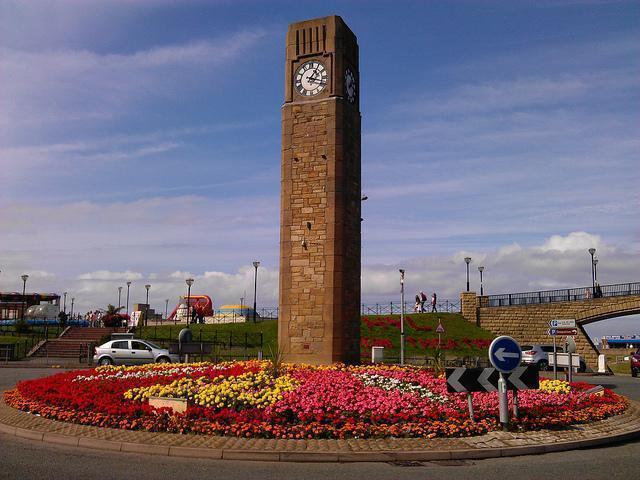What is the traffic pattern?
Select the accurate response from the four choices given to answer the question.
Options: Intersection, dead end, highway, traffic circle. Intersection. 